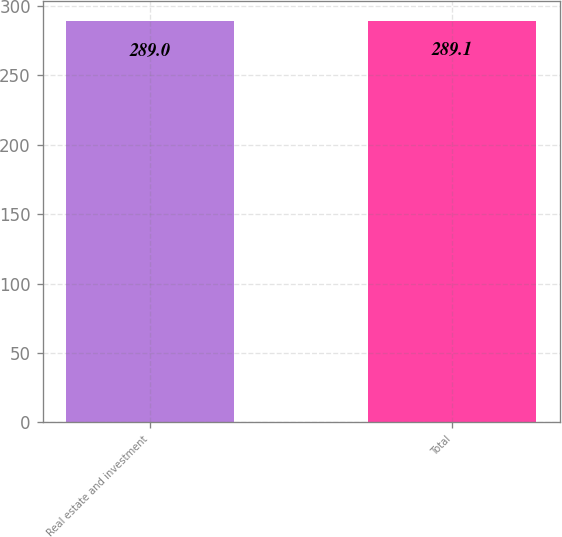Convert chart to OTSL. <chart><loc_0><loc_0><loc_500><loc_500><bar_chart><fcel>Real estate and investment<fcel>Total<nl><fcel>289<fcel>289.1<nl></chart> 